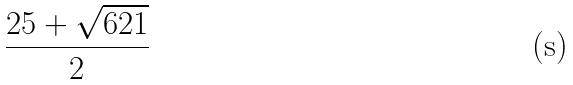Convert formula to latex. <formula><loc_0><loc_0><loc_500><loc_500>\frac { 2 5 + \sqrt { 6 2 1 } } { 2 }</formula> 